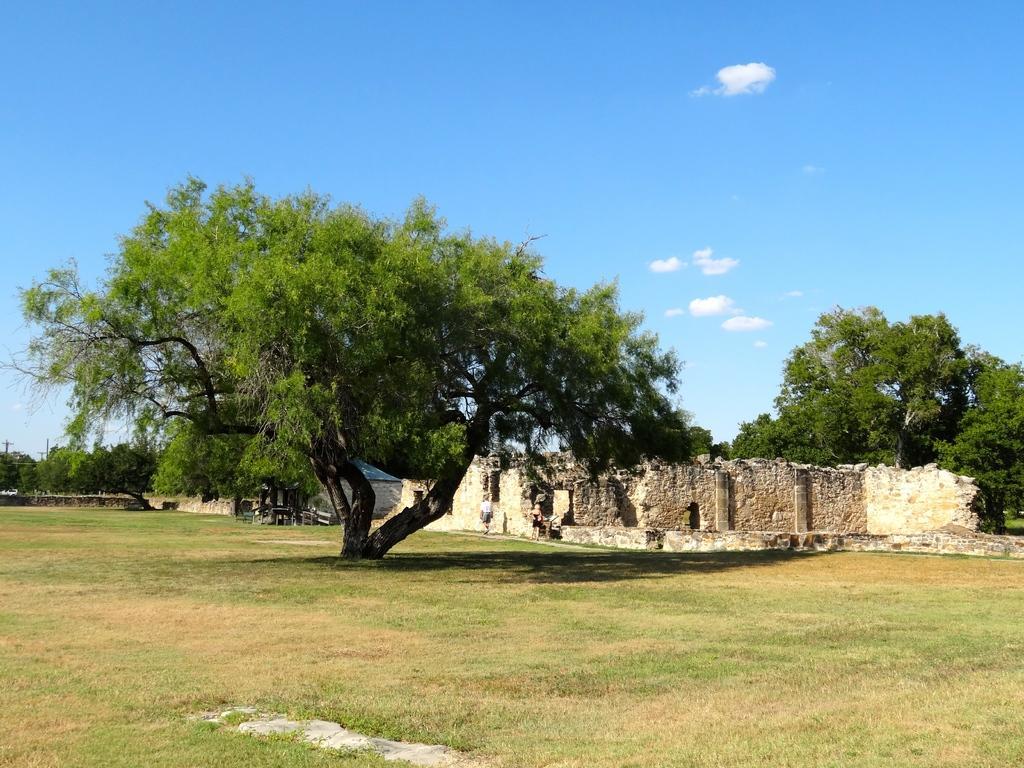In one or two sentences, can you explain what this image depicts? In this picture I can see few persons. I can see buildings, trees, and in the background there is the sky. 